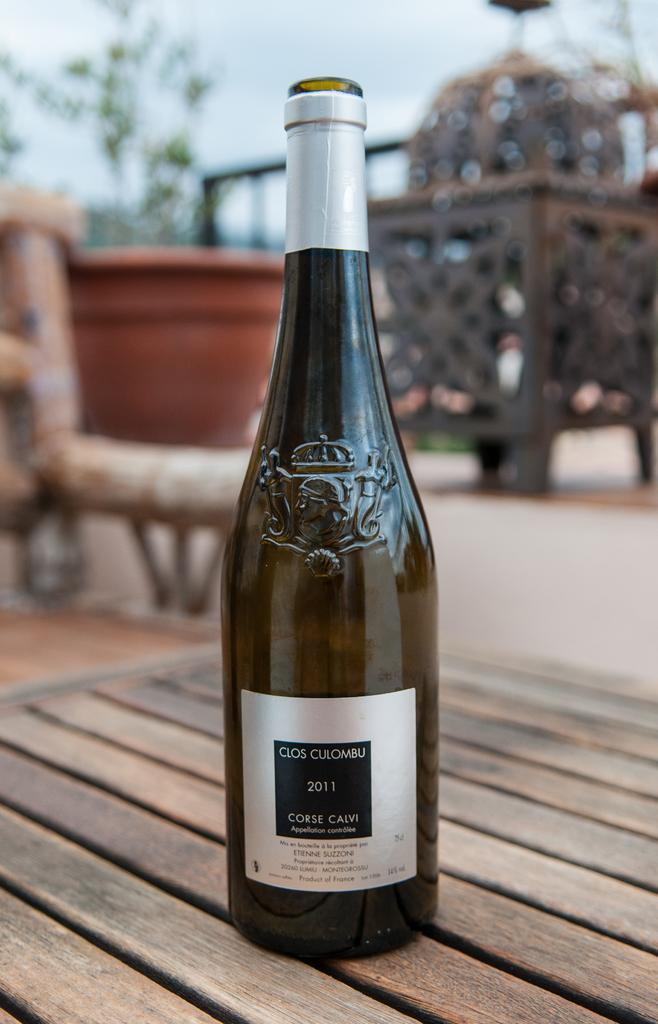Provide a one-sentence caption for the provided image. Wine in a bottle from the year of 2011. 